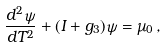Convert formula to latex. <formula><loc_0><loc_0><loc_500><loc_500>\frac { d ^ { 2 } \psi } { d T ^ { 2 } } + ( I + g _ { 3 } ) \psi = \mu _ { 0 } \, ,</formula> 